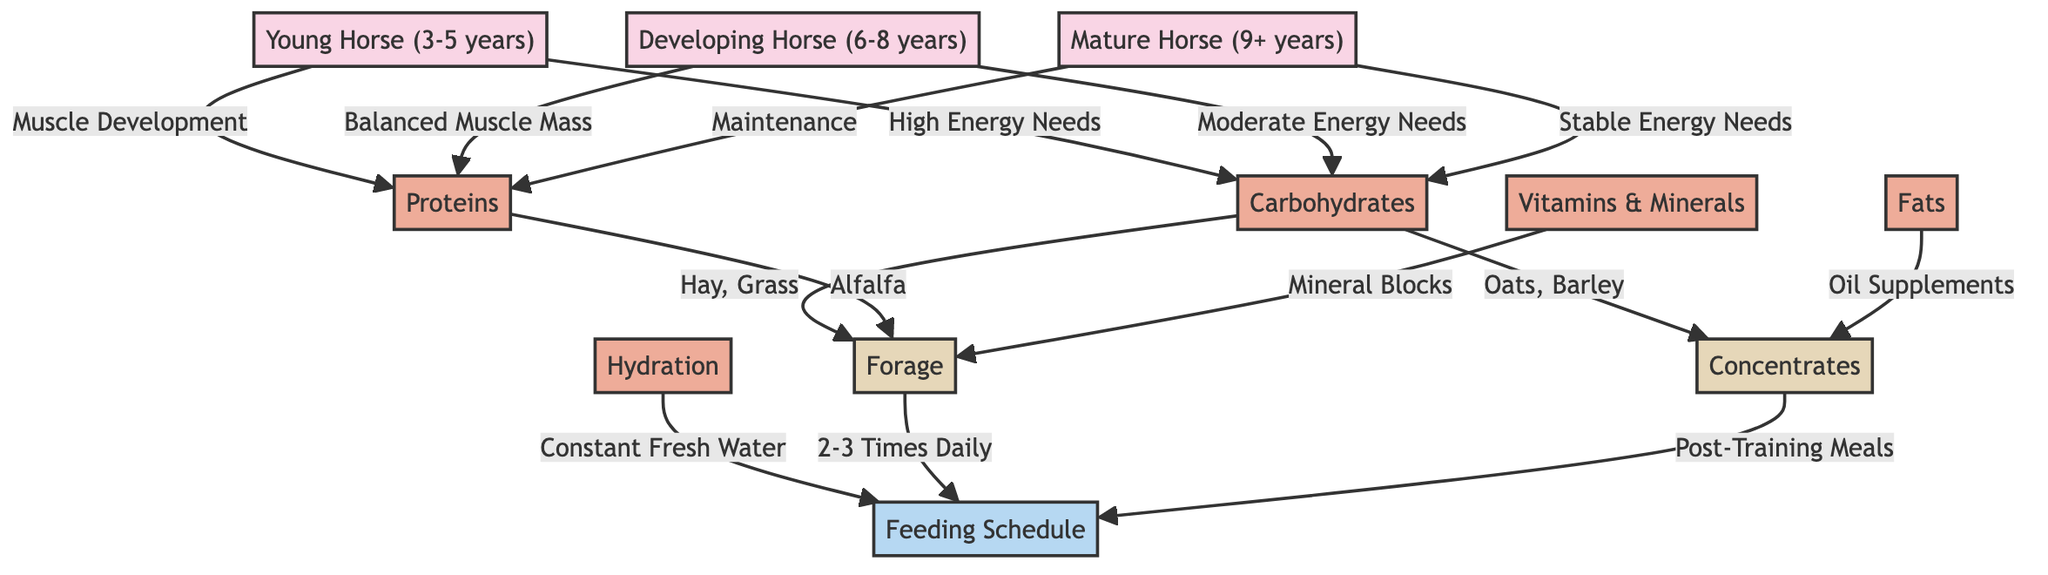What nutrient is essential for muscle development in young horses? The diagram shows that the nutrient associated with muscle development specifically for young horses is proteins. This is indicated by the arrow connecting young horses to proteins labeled "Muscle Development."
Answer: proteins What is the primary source of carbohydrates mentioned in the diagram? The diagram indicates that the primary sources of carbohydrates are hay and grass, as shown by the connection from carbohydrates to forage labeled "Hay, Grass."
Answer: Hay, Grass How many types of horses are listed in the diagram? The diagram contains three types of horses: Young Horse, Developing Horse, and Mature Horse. By counting the distinct horse nodes, we find that there are three.
Answer: 3 What do mature horses primarily require for energy according to the diagram? The diagram states that mature horses have stable energy needs and they require carbohydrates as indicated by the arrow leading from mature horses to carbohydrates labeled "Stable Energy Needs."
Answer: carbohydrates What is the feeding schedule for forage mentioned in the diagram? The diagram specifies that forage should be fed 2-3 times daily, as shown by the connection from forage to the feeding schedule with the label "2-3 Times Daily."
Answer: 2-3 Times Daily What is the role of hydration in the feeding schedule? According to the diagram, hydration is essential and indicates "Constant Fresh Water" as a requirement that leads to the feeding schedule, demonstrating its importance in overall nutrition and feeding.
Answer: Constant Fresh Water Which nutrient is recommended as an oil supplement for fats? The diagram suggests that oil supplements are the recommended source for fats, indicated in the flow from fats to concentrates labeled "Oil Supplements."
Answer: Oil Supplements How does the energy need change from young to mature horses? The diagram shows that young horses have high energy needs, developing horses have moderate energy needs, and mature horses have stable energy needs. Therefore, the energy requirement decreases as the horses mature.
Answer: Decreases 